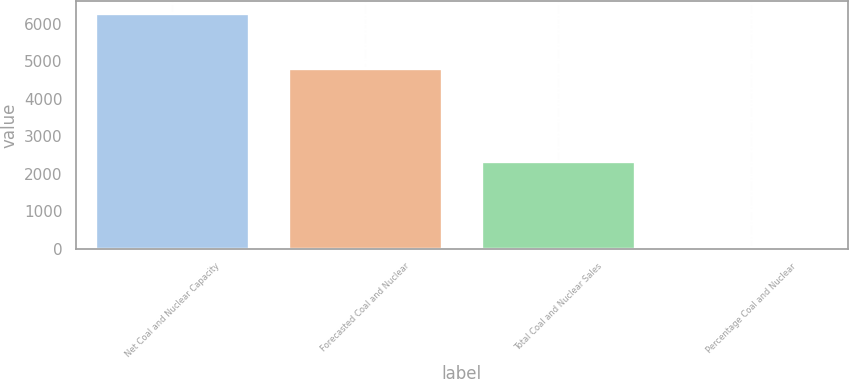Convert chart. <chart><loc_0><loc_0><loc_500><loc_500><bar_chart><fcel>Net Coal and Nuclear Capacity<fcel>Forecasted Coal and Nuclear<fcel>Total Coal and Nuclear Sales<fcel>Percentage Coal and Nuclear<nl><fcel>6290<fcel>4817<fcel>2329<fcel>48<nl></chart> 